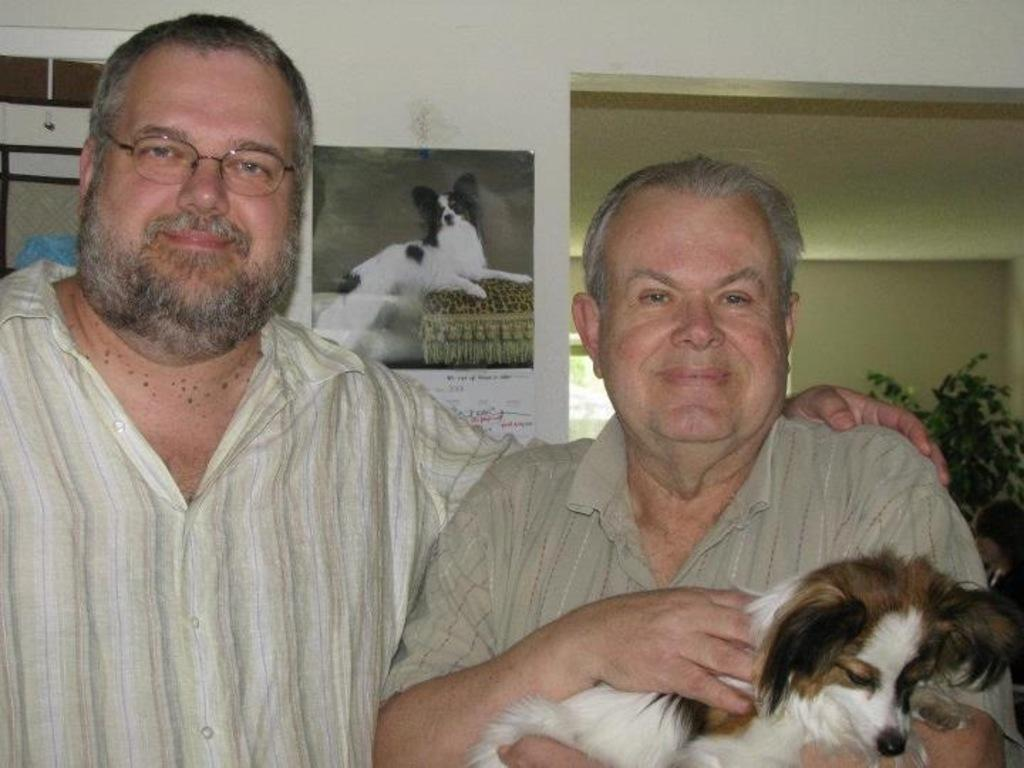How many people are in the image? There are two persons in the image. What is the person on the right side holding? The person on the right side is holding a dog. What is the facial expression of both persons in the image? Both persons are smiling. What type of pot is visible on the hill in the image? There is no pot or hill present in the image. 